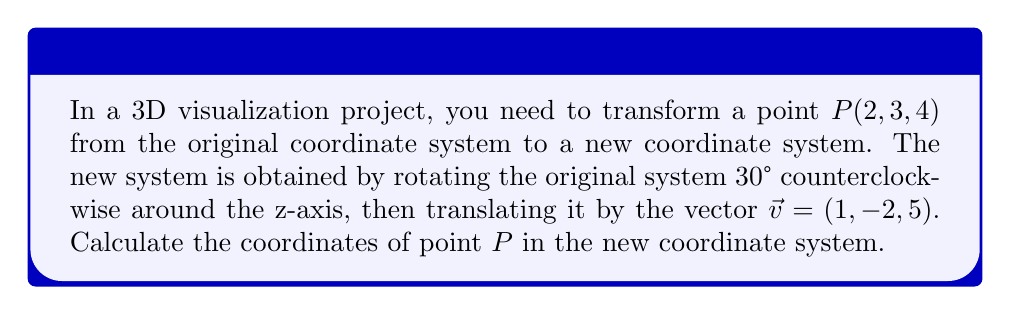Provide a solution to this math problem. To solve this problem, we need to apply the rotation and translation transformations in sequence:

1. Rotation around the z-axis:
The rotation matrix for a counterclockwise rotation of $\theta$ degrees around the z-axis is:

$$R_z(\theta) = \begin{pmatrix}
\cos\theta & -\sin\theta & 0 \\
\sin\theta & \cos\theta & 0 \\
0 & 0 & 1
\end{pmatrix}$$

For $\theta = 30°$, we have:

$$R_z(30°) = \begin{pmatrix}
\frac{\sqrt{3}}{2} & -\frac{1}{2} & 0 \\
\frac{1}{2} & \frac{\sqrt{3}}{2} & 0 \\
0 & 0 & 1
\end{pmatrix}$$

2. Apply the rotation to point $P(2, 3, 4)$:

$$\begin{pmatrix}
\frac{\sqrt{3}}{2} & -\frac{1}{2} & 0 \\
\frac{1}{2} & \frac{\sqrt{3}}{2} & 0 \\
0 & 0 & 1
\end{pmatrix} \begin{pmatrix}
2 \\
3 \\
4
\end{pmatrix} = \begin{pmatrix}
\frac{\sqrt{3}}{2}(2) - \frac{1}{2}(3) \\
\frac{1}{2}(2) + \frac{\sqrt{3}}{2}(3) \\
4
\end{pmatrix} = \begin{pmatrix}
\sqrt{3} - \frac{3}{2} \\
1 + \frac{3\sqrt{3}}{2} \\
4
\end{pmatrix}$$

3. Translation:
After rotation, we apply the translation vector $\vec{v} = (1, -2, 5)$:

$$\begin{pmatrix}
\sqrt{3} - \frac{3}{2} + 1 \\
1 + \frac{3\sqrt{3}}{2} - 2 \\
4 + 5
\end{pmatrix} = \begin{pmatrix}
\sqrt{3} - \frac{1}{2} \\
\frac{3\sqrt{3}}{2} - 1 \\
9
\end{pmatrix}$$

Therefore, the coordinates of point $P$ in the new coordinate system are $(\sqrt{3} - \frac{1}{2}, \frac{3\sqrt{3}}{2} - 1, 9)$.
Answer: $(\sqrt{3} - \frac{1}{2}, \frac{3\sqrt{3}}{2} - 1, 9)$ 